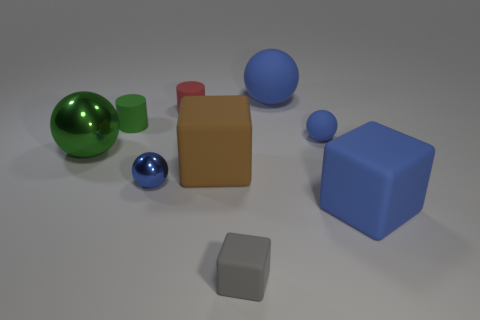Subtract all blue spheres. How many were subtracted if there are2blue spheres left? 1 Subtract all blue blocks. How many blue spheres are left? 3 Subtract all balls. How many objects are left? 5 Add 8 small red matte cylinders. How many small red matte cylinders are left? 9 Add 5 small blue shiny objects. How many small blue shiny objects exist? 6 Subtract 1 red cylinders. How many objects are left? 8 Subtract all large rubber balls. Subtract all red matte cylinders. How many objects are left? 7 